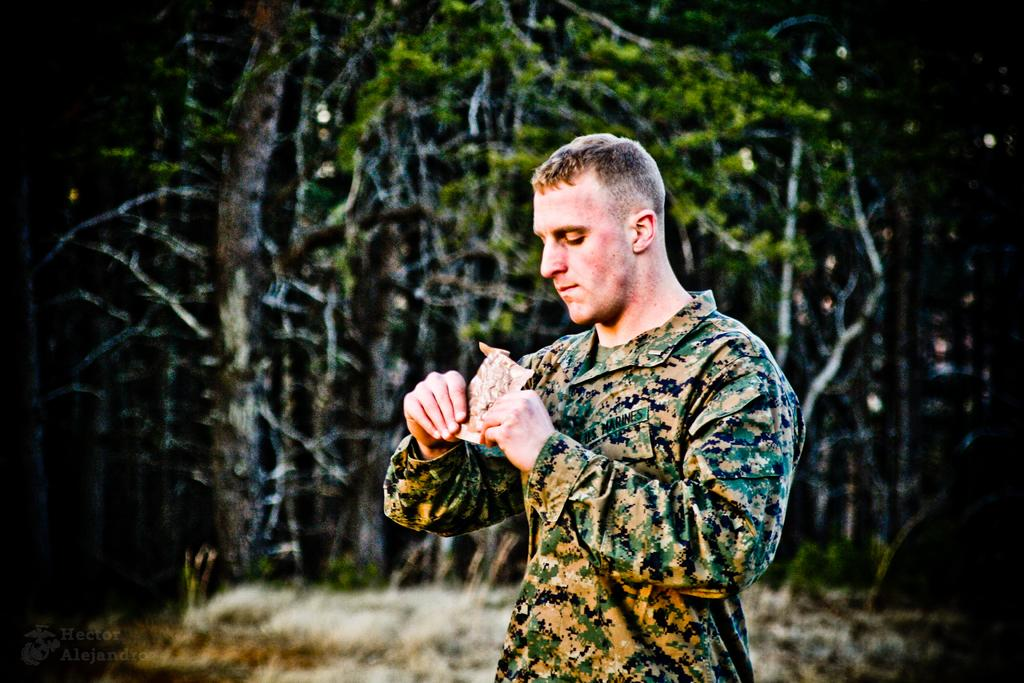Who is present in the image? There is a man in the image. What is the man doing in the image? The man is holding an object with both hands. What can be seen in the background of the image? There are many trees behind the man. What type of lock can be seen on the object the man is holding? There is no lock present on the object the man is holding in the image. 